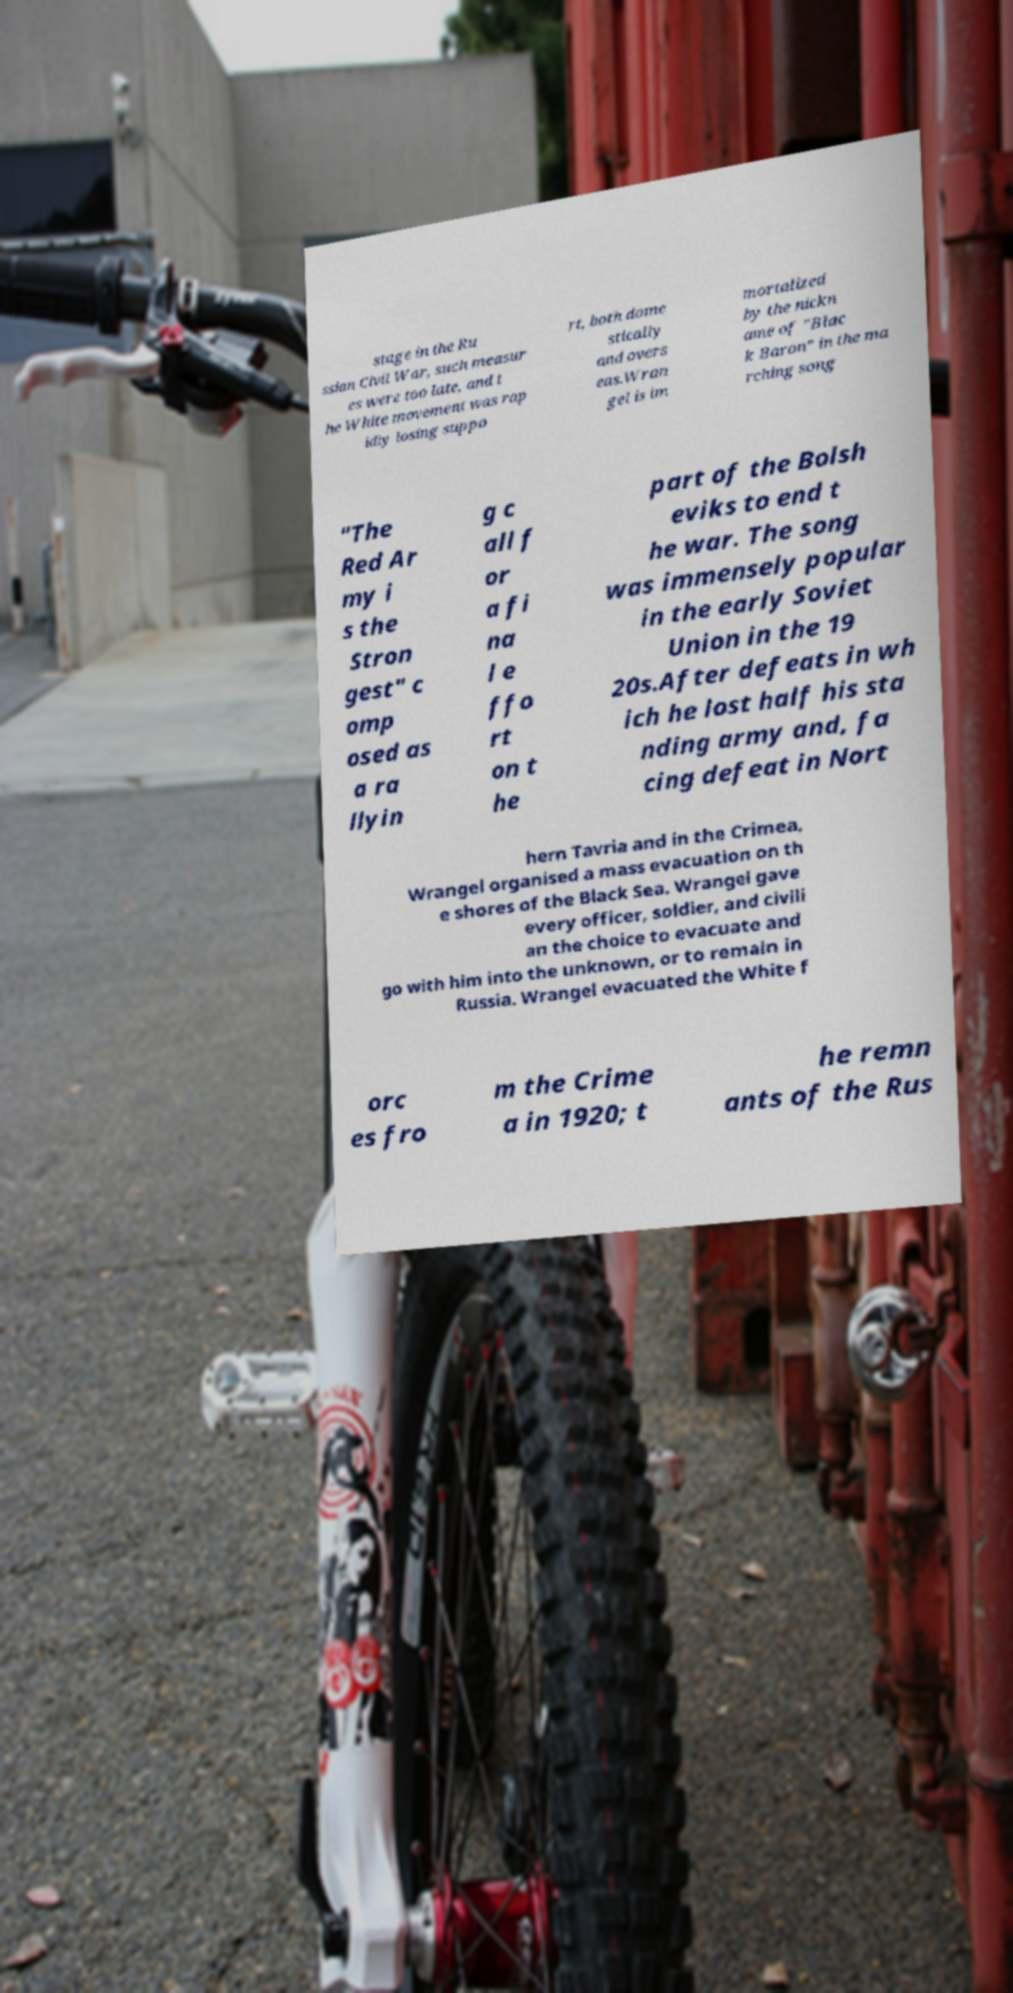Could you assist in decoding the text presented in this image and type it out clearly? stage in the Ru ssian Civil War, such measur es were too late, and t he White movement was rap idly losing suppo rt, both dome stically and overs eas.Wran gel is im mortalized by the nickn ame of "Blac k Baron" in the ma rching song "The Red Ar my i s the Stron gest" c omp osed as a ra llyin g c all f or a fi na l e ffo rt on t he part of the Bolsh eviks to end t he war. The song was immensely popular in the early Soviet Union in the 19 20s.After defeats in wh ich he lost half his sta nding army and, fa cing defeat in Nort hern Tavria and in the Crimea, Wrangel organised a mass evacuation on th e shores of the Black Sea. Wrangel gave every officer, soldier, and civili an the choice to evacuate and go with him into the unknown, or to remain in Russia. Wrangel evacuated the White f orc es fro m the Crime a in 1920; t he remn ants of the Rus 